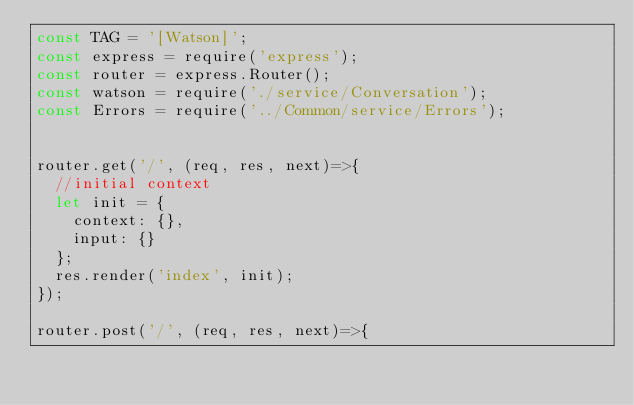<code> <loc_0><loc_0><loc_500><loc_500><_JavaScript_>const TAG = '[Watson]';
const express = require('express');
const router = express.Router();
const watson = require('./service/Conversation');
const Errors = require('../Common/service/Errors');


router.get('/', (req, res, next)=>{
  //initial context
  let init = {
    context: {},
    input: {}
  };
  res.render('index', init);
});

router.post('/', (req, res, next)=>{</code> 